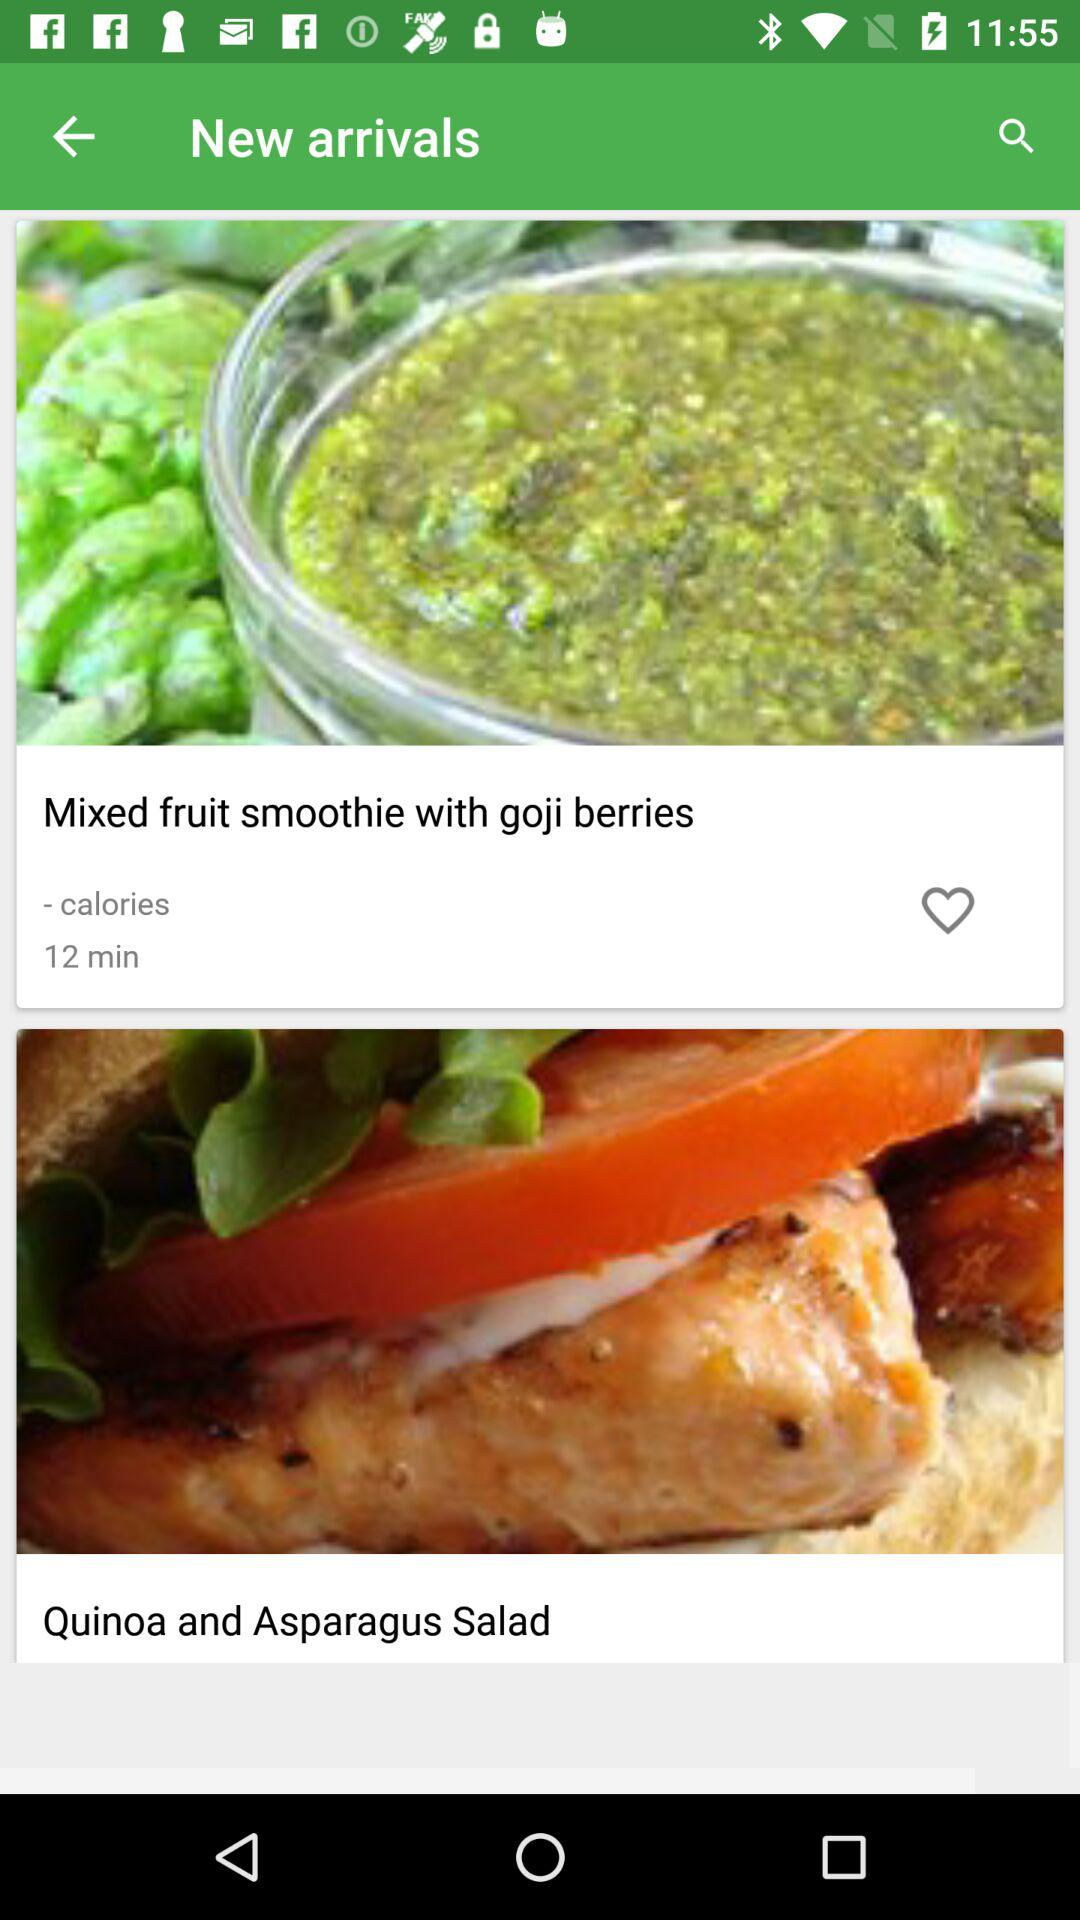How much time is required to make "Mixed fruit smoothie with goji berries"? The required time is 12 minutes. 